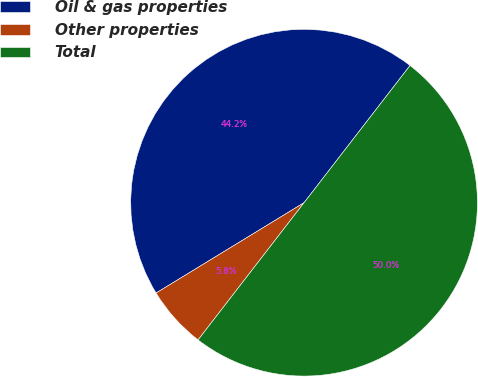<chart> <loc_0><loc_0><loc_500><loc_500><pie_chart><fcel>Oil & gas properties<fcel>Other properties<fcel>Total<nl><fcel>44.19%<fcel>5.81%<fcel>50.0%<nl></chart> 